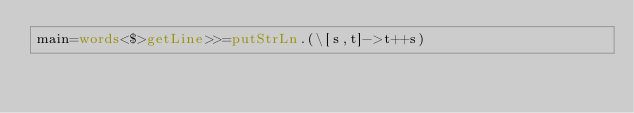<code> <loc_0><loc_0><loc_500><loc_500><_Haskell_>main=words<$>getLine>>=putStrLn.(\[s,t]->t++s)</code> 